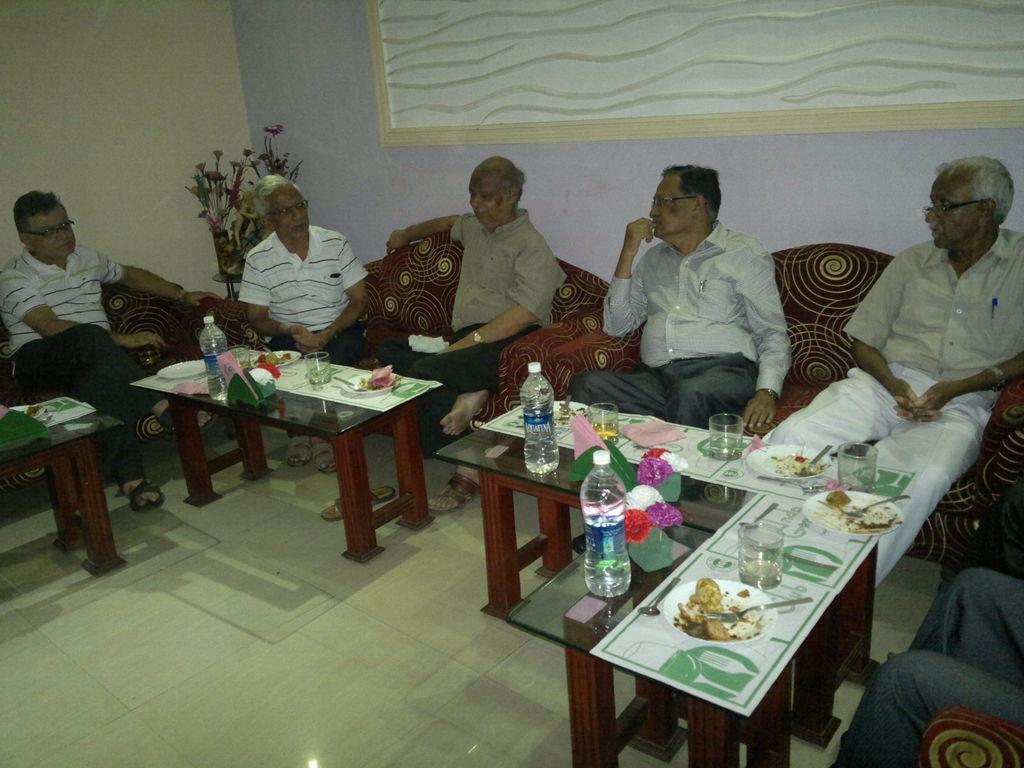Please provide a concise description of this image. This is a picture of a room, where many people are seated in couches. In the center of the image there are tables, on this tables there are bottles, glasses, plates, food and spoons. In the top left there is a flower vase. On the background wall there is a design. 